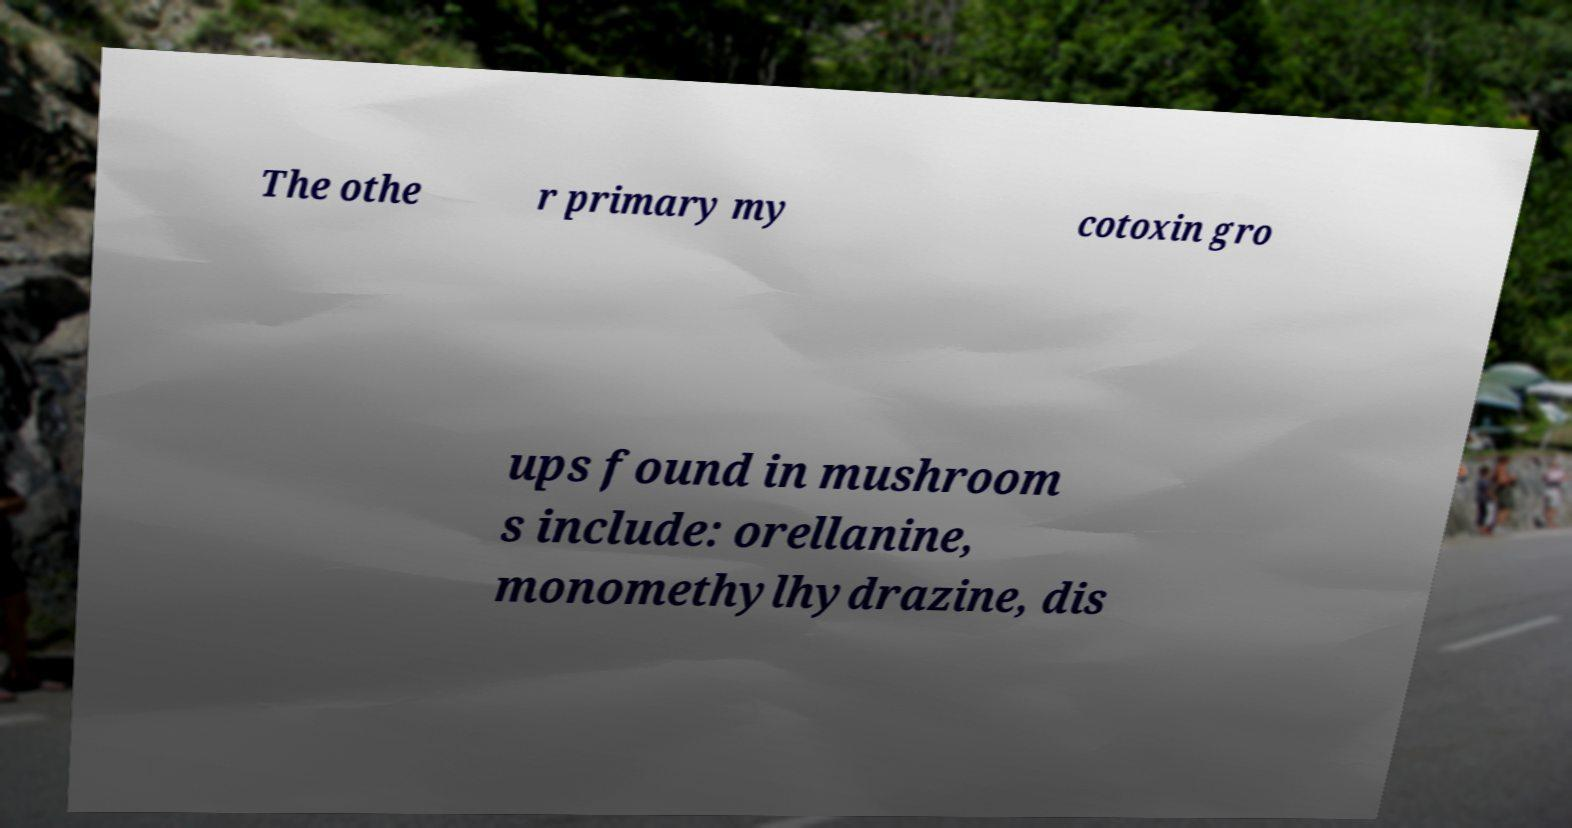For documentation purposes, I need the text within this image transcribed. Could you provide that? The othe r primary my cotoxin gro ups found in mushroom s include: orellanine, monomethylhydrazine, dis 